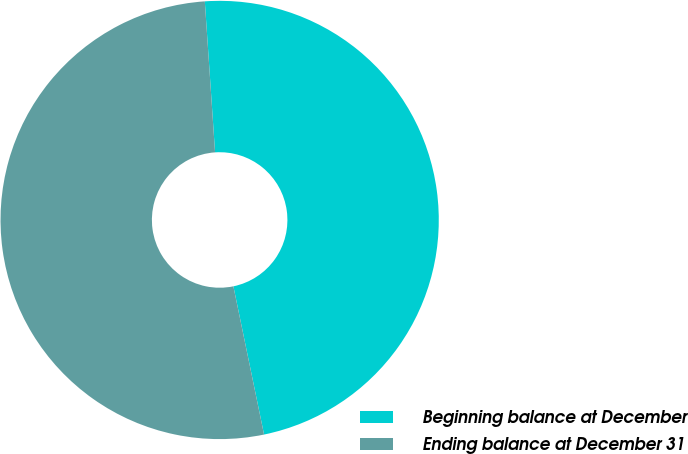<chart> <loc_0><loc_0><loc_500><loc_500><pie_chart><fcel>Beginning balance at December<fcel>Ending balance at December 31<nl><fcel>47.83%<fcel>52.17%<nl></chart> 